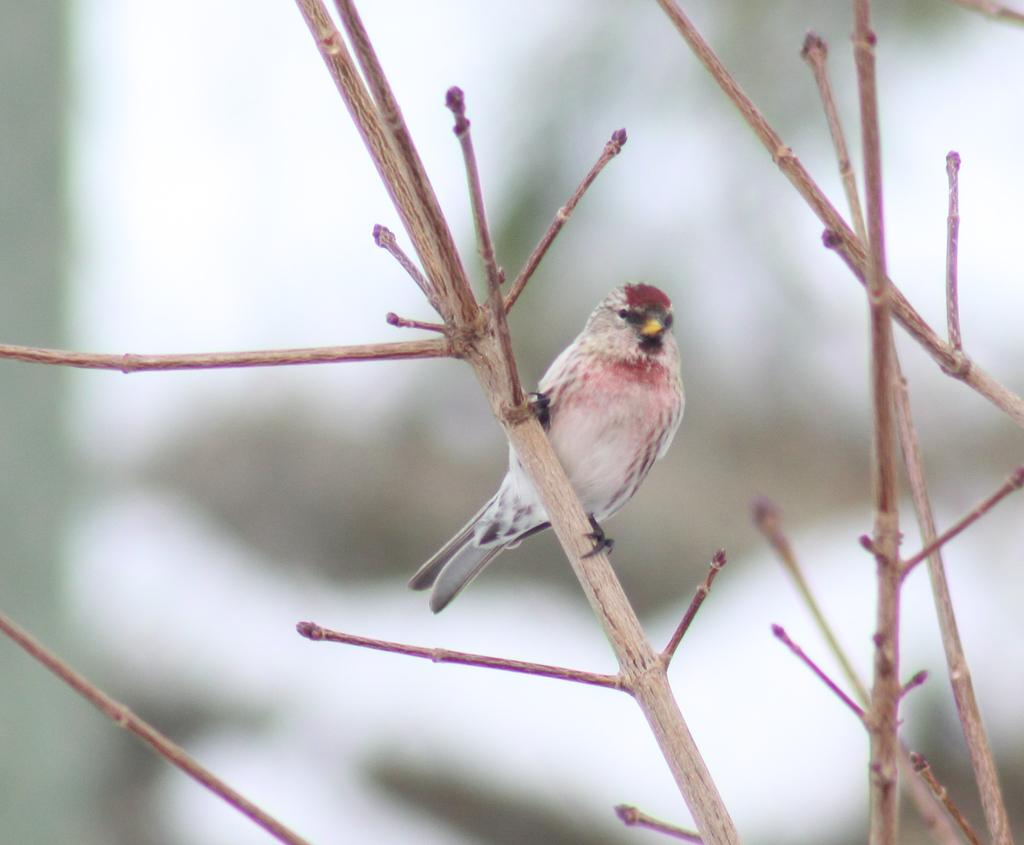What type of animal can be seen in the image? There is a bird in the image. Where is the bird located? The bird is standing on a branch of a tree. What colors can be observed on the bird? The bird has white and red coloration. How would you describe the background of the image? The background of the image is blurred. What type of meat is being stored in the box in the image? There is no box or meat present in the image; it features a bird standing on a tree branch. 